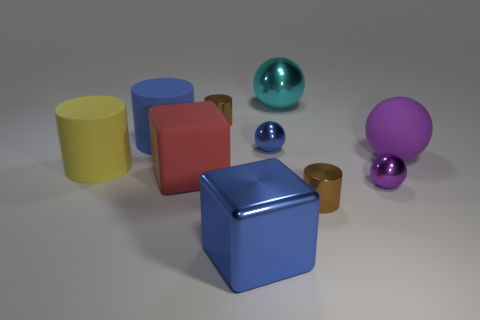Subtract all large yellow matte cylinders. How many cylinders are left? 3 Subtract all brown cylinders. How many purple spheres are left? 2 Subtract all yellow cylinders. How many cylinders are left? 3 Subtract all green spheres. Subtract all purple cubes. How many spheres are left? 4 Subtract all purple shiny objects. Subtract all blue rubber cylinders. How many objects are left? 8 Add 2 matte spheres. How many matte spheres are left? 3 Add 7 tiny brown cylinders. How many tiny brown cylinders exist? 9 Subtract 0 green cubes. How many objects are left? 10 Subtract all cylinders. How many objects are left? 6 